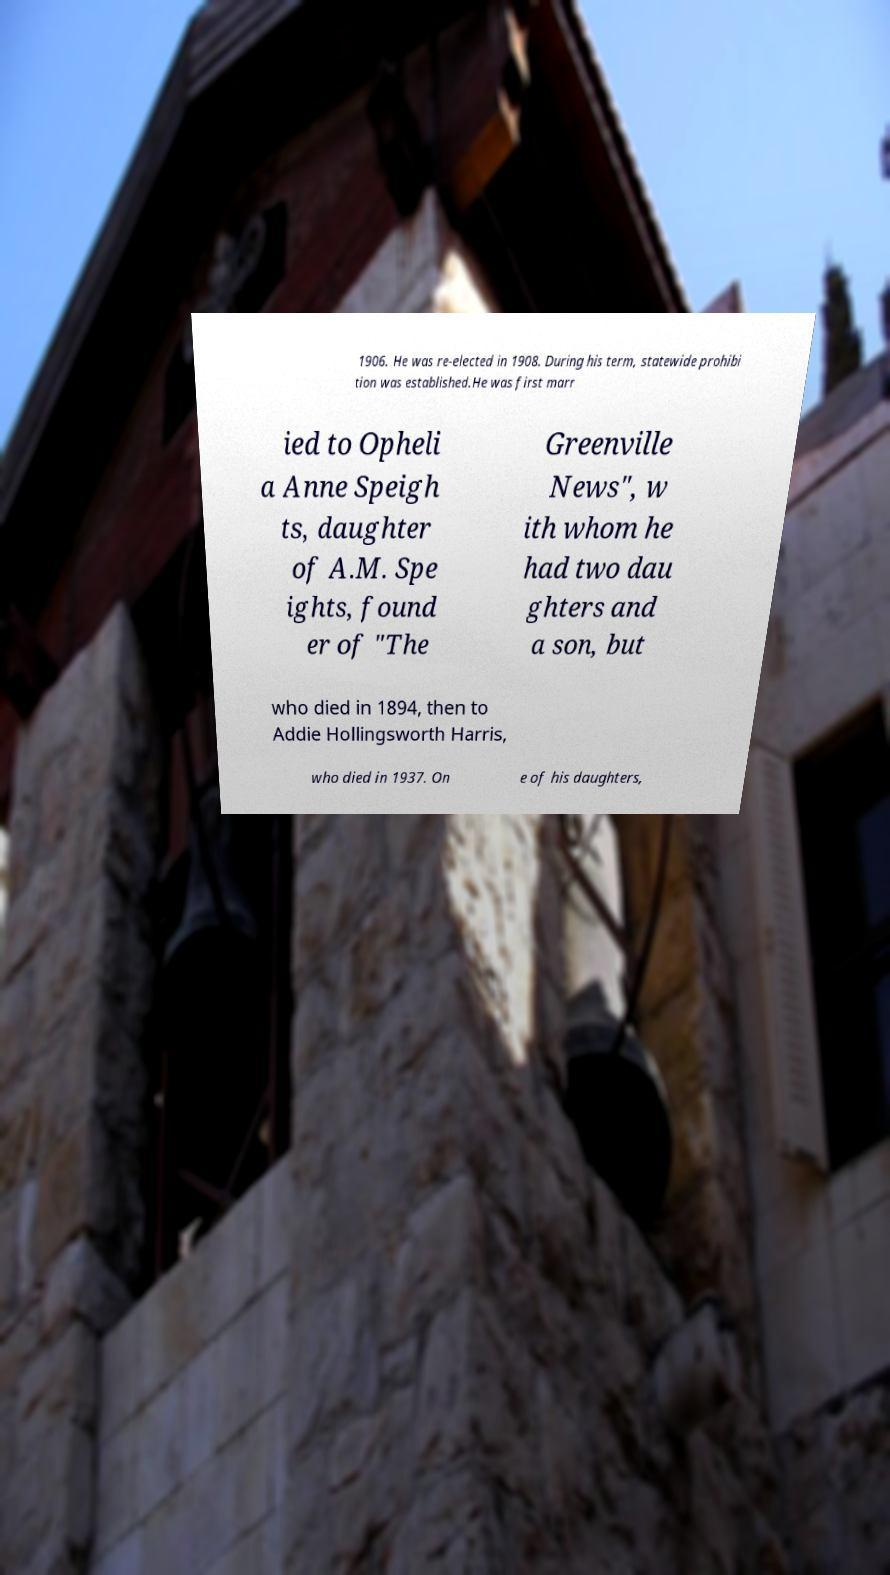I need the written content from this picture converted into text. Can you do that? 1906. He was re-elected in 1908. During his term, statewide prohibi tion was established.He was first marr ied to Opheli a Anne Speigh ts, daughter of A.M. Spe ights, found er of "The Greenville News", w ith whom he had two dau ghters and a son, but who died in 1894, then to Addie Hollingsworth Harris, who died in 1937. On e of his daughters, 